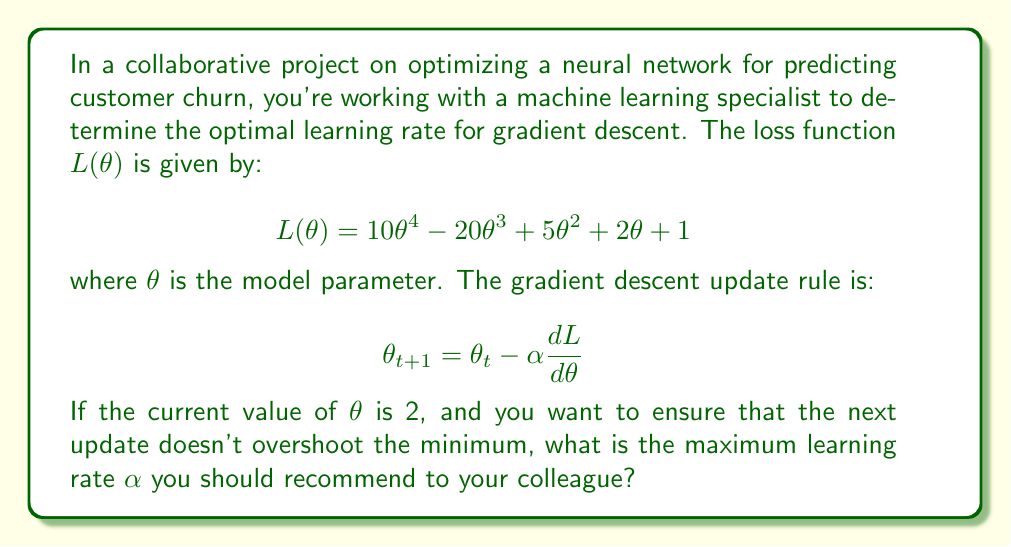What is the answer to this math problem? To determine the maximum learning rate, we need to follow these steps:

1. Calculate the gradient of the loss function:
   $$\frac{dL}{d\theta} = 40\theta^3 - 60\theta^2 + 10\theta + 2$$

2. Evaluate the gradient at $\theta = 2$:
   $$\frac{dL}{d\theta}\bigg|_{\theta=2} = 40(2^3) - 60(2^2) + 10(2) + 2 = 320 - 240 + 20 + 2 = 102$$

3. The gradient descent update rule is:
   $$\theta_{t+1} = \theta_t - \alpha \frac{dL}{d\theta}$$
   
   Substituting the known values:
   $$\theta_{t+1} = 2 - 102\alpha$$

4. To avoid overshooting, we want $\theta_{t+1}$ to be greater than the minimum of the function. The minimum occurs where the gradient is zero. We can find this by solving:
   $$40\theta^3 - 60\theta^2 + 10\theta + 2 = 0$$
   
   This is a cubic equation and solving it exactly is complex. However, we can observe that $\theta = 1$ is close to the minimum (you can verify this by plugging in values slightly above and below 1).

5. To ensure we don't overshoot, we want:
   $$\theta_{t+1} > 1$$
   
   Substituting our update rule:
   $$2 - 102\alpha > 1$$
   $$-102\alpha > -1$$
   $$\alpha < \frac{1}{102}$$

Therefore, the maximum learning rate should be slightly less than $\frac{1}{102}$ to ensure we don't overshoot the minimum.
Answer: The maximum recommended learning rate $\alpha$ is $\frac{1}{102} \approx 0.0098$. 